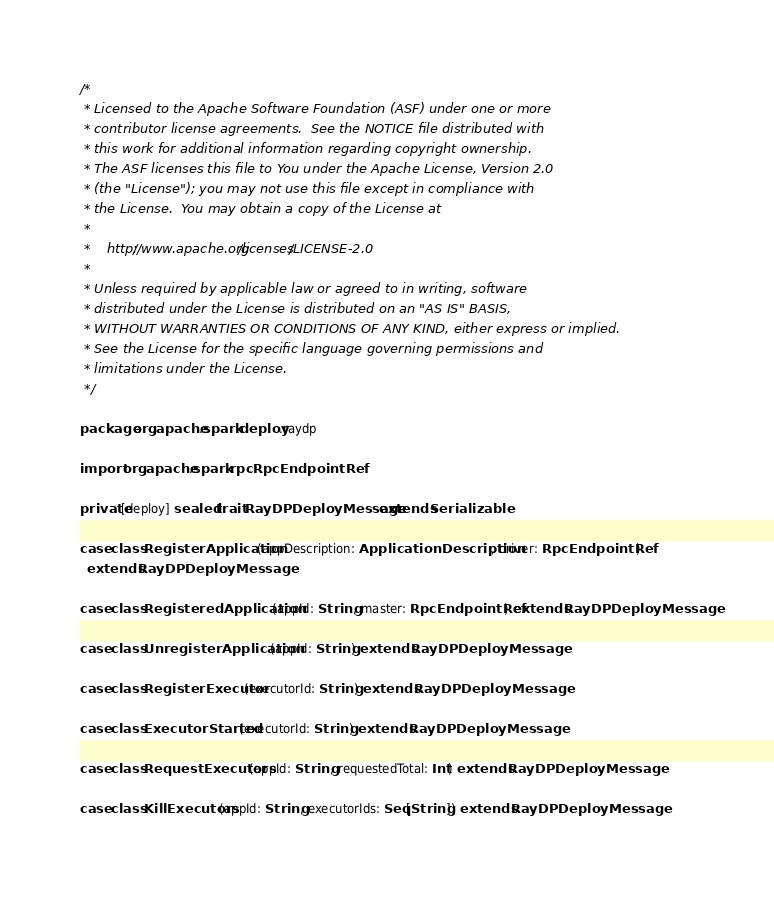Convert code to text. <code><loc_0><loc_0><loc_500><loc_500><_Scala_>/*
 * Licensed to the Apache Software Foundation (ASF) under one or more
 * contributor license agreements.  See the NOTICE file distributed with
 * this work for additional information regarding copyright ownership.
 * The ASF licenses this file to You under the Apache License, Version 2.0
 * (the "License"); you may not use this file except in compliance with
 * the License.  You may obtain a copy of the License at
 *
 *    http://www.apache.org/licenses/LICENSE-2.0
 *
 * Unless required by applicable law or agreed to in writing, software
 * distributed under the License is distributed on an "AS IS" BASIS,
 * WITHOUT WARRANTIES OR CONDITIONS OF ANY KIND, either express or implied.
 * See the License for the specific language governing permissions and
 * limitations under the License.
 */

package org.apache.spark.deploy.raydp

import org.apache.spark.rpc.RpcEndpointRef

private[deploy] sealed trait RayDPDeployMessage extends Serializable

case class RegisterApplication(appDescription: ApplicationDescription, driver: RpcEndpointRef)
  extends RayDPDeployMessage

case class RegisteredApplication(appId: String, master: RpcEndpointRef) extends RayDPDeployMessage

case class UnregisterApplication(appId: String) extends RayDPDeployMessage

case class RegisterExecutor(executorId: String) extends RayDPDeployMessage

case class ExecutorStarted(executorId: String) extends RayDPDeployMessage

case class RequestExecutors(appId: String, requestedTotal: Int) extends RayDPDeployMessage

case class KillExecutors(appId: String, executorIds: Seq[String]) extends RayDPDeployMessage
</code> 